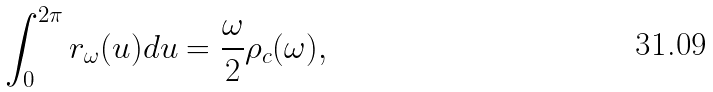<formula> <loc_0><loc_0><loc_500><loc_500>\int _ { 0 } ^ { 2 \pi } { r _ { \omega } ( u ) d u } = \frac { \omega } { 2 } \rho _ { c } ( \omega ) ,</formula> 